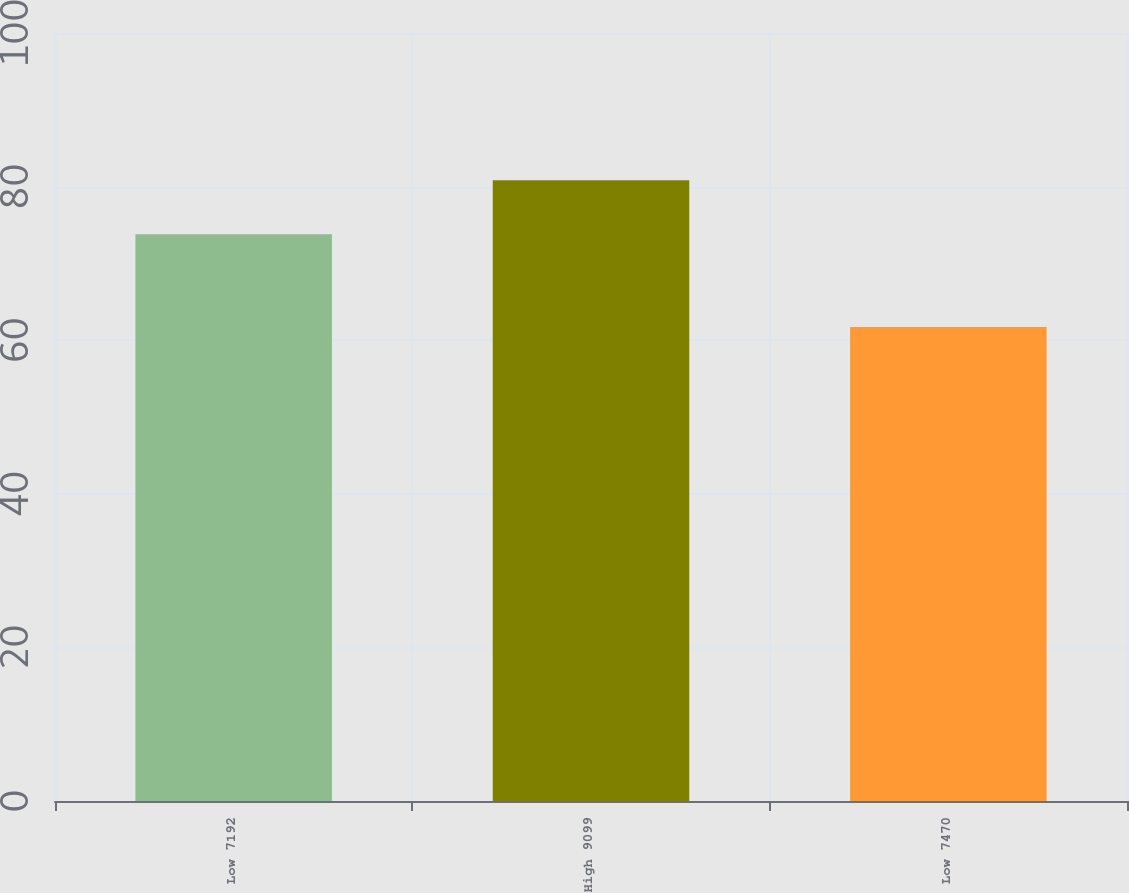Convert chart to OTSL. <chart><loc_0><loc_0><loc_500><loc_500><bar_chart><fcel>Low 7192<fcel>High 9099<fcel>Low 7470<nl><fcel>73.81<fcel>80.82<fcel>61.72<nl></chart> 